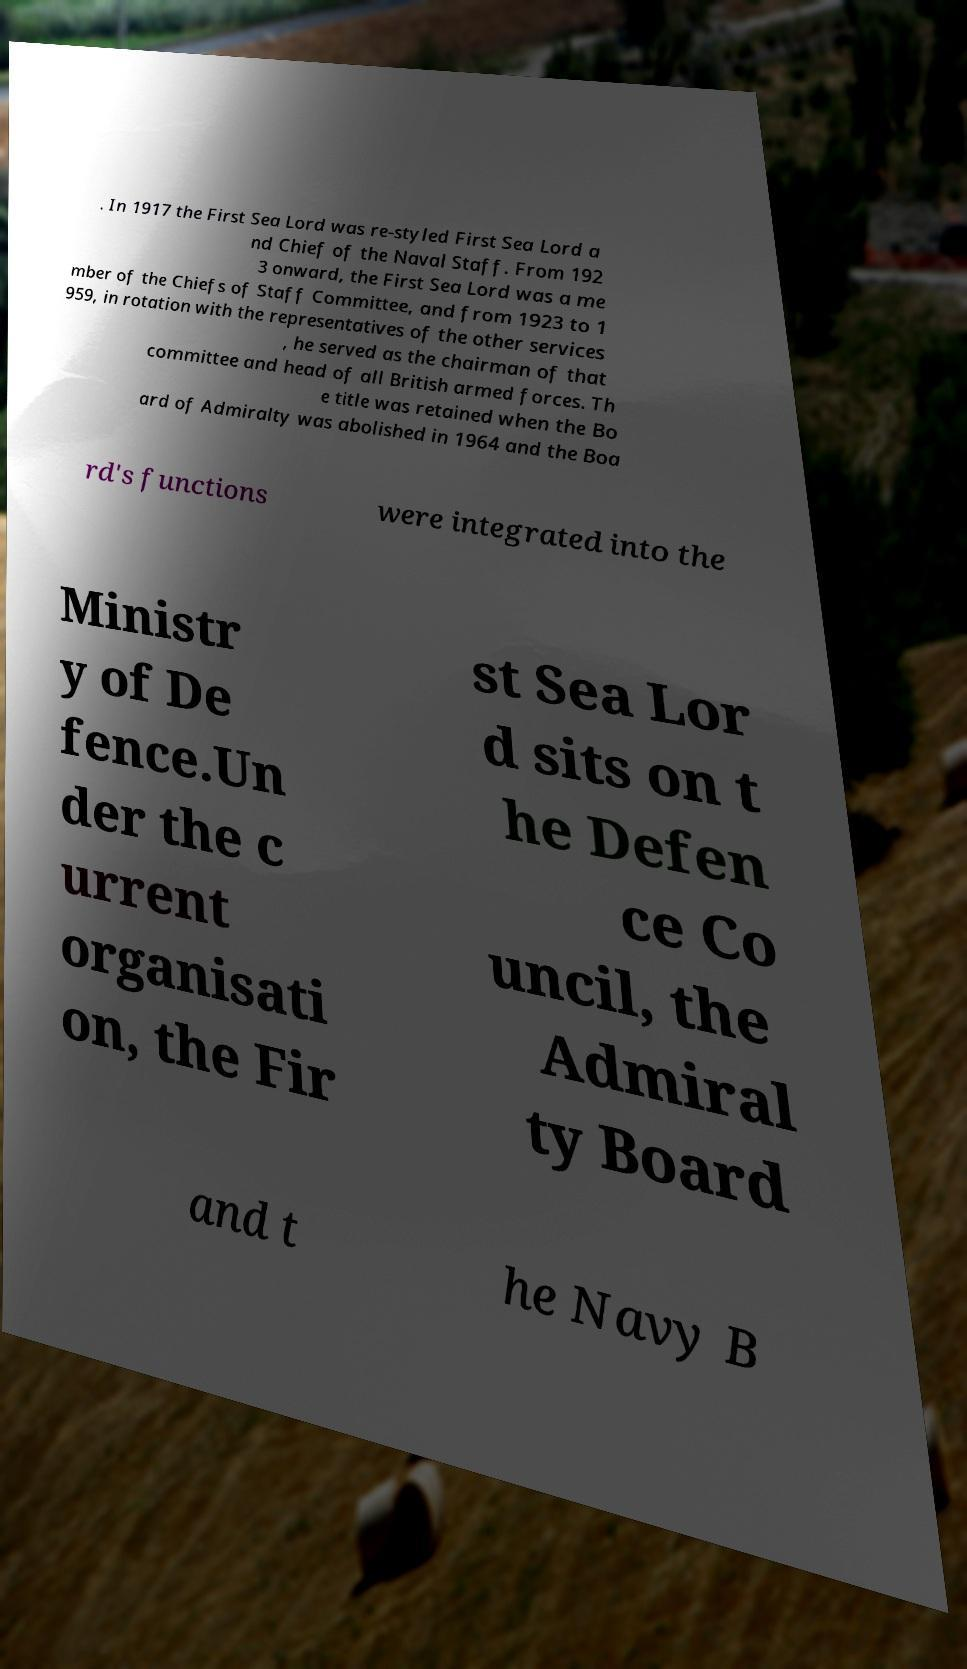Please read and relay the text visible in this image. What does it say? . In 1917 the First Sea Lord was re-styled First Sea Lord a nd Chief of the Naval Staff. From 192 3 onward, the First Sea Lord was a me mber of the Chiefs of Staff Committee, and from 1923 to 1 959, in rotation with the representatives of the other services , he served as the chairman of that committee and head of all British armed forces. Th e title was retained when the Bo ard of Admiralty was abolished in 1964 and the Boa rd's functions were integrated into the Ministr y of De fence.Un der the c urrent organisati on, the Fir st Sea Lor d sits on t he Defen ce Co uncil, the Admiral ty Board and t he Navy B 